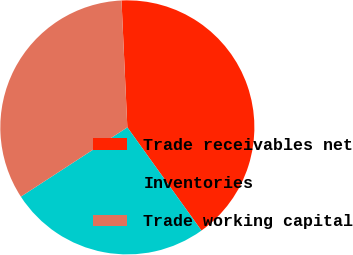<chart> <loc_0><loc_0><loc_500><loc_500><pie_chart><fcel>Trade receivables net<fcel>Inventories<fcel>Trade working capital<nl><fcel>40.82%<fcel>25.73%<fcel>33.45%<nl></chart> 